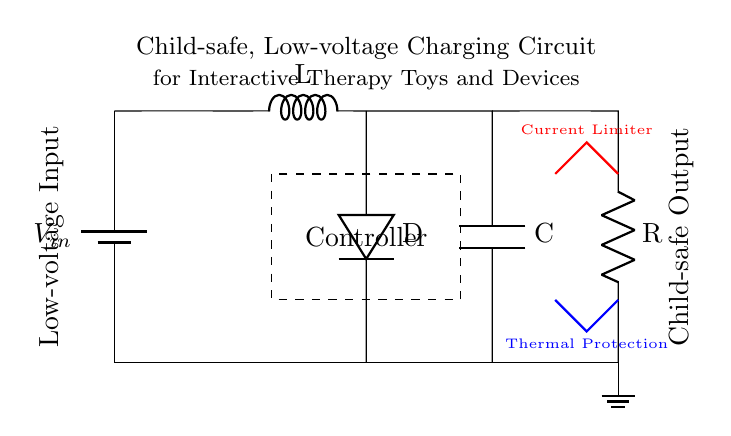What type of circuit is this? This is a charging circuit designed for low-voltage applications, suitable for interactive therapy toys and devices.
Answer: Charging What component is used for current limiting? The component indicated by the thick red line is the current limiter, which helps prevent excessive current from damaging the circuit or devices.
Answer: Current Limiter What is the role of the voltage regulator in this circuit? The voltage regulator ensures a stable output voltage, even if the input voltage varies, maintaining safe operating conditions for the connected devices.
Answer: Voltage Regulator What safety feature is indicated by the blue line? The blue line indicates thermal protection, which helps prevent overheating in the circuit to ensure the safety of both the device and the users.
Answer: Thermal Protection What does the dashed rectangle represent? The dashed rectangle encloses the controller, which manages the charging process and ensures that the charging occurs safely and efficiently.
Answer: Controller What is the input voltage labeled as? The input voltage is labeled as V in, which indicates the voltage supplied to the circuit from the battery.
Answer: V in What is the output configuration for the charged devices? The output of the circuit is described as Child-safe Output, indicating that the output configuration is designed with safety features for children.
Answer: Child-safe Output 